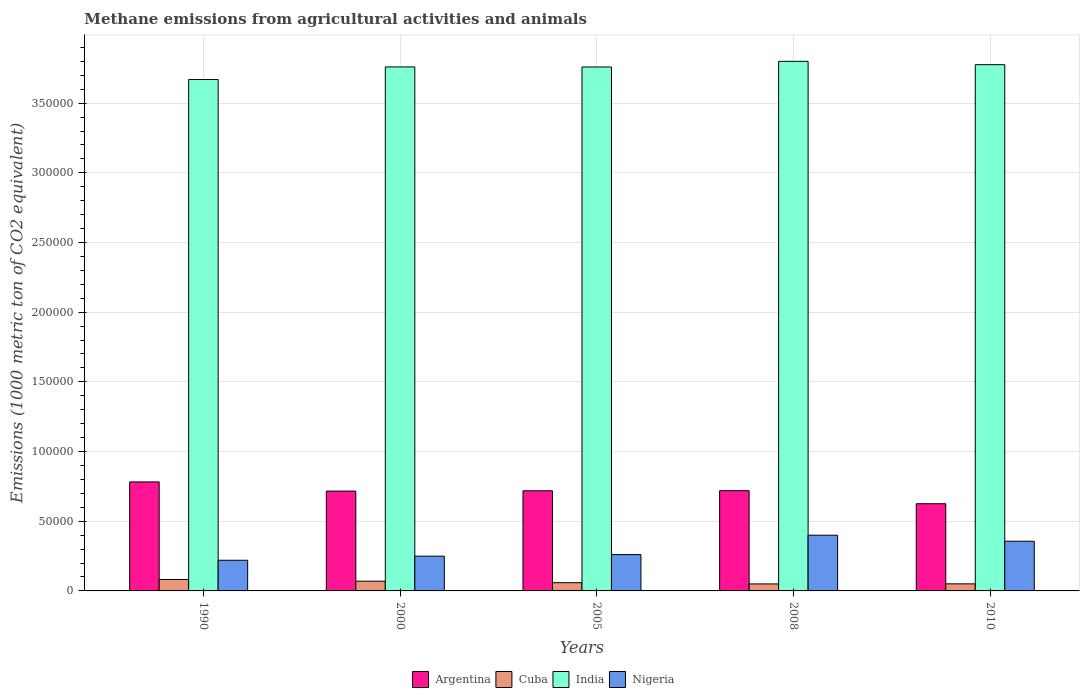How many groups of bars are there?
Your answer should be very brief. 5. Are the number of bars on each tick of the X-axis equal?
Give a very brief answer. Yes. In how many cases, is the number of bars for a given year not equal to the number of legend labels?
Provide a short and direct response. 0. What is the amount of methane emitted in Nigeria in 2008?
Offer a very short reply. 4.00e+04. Across all years, what is the maximum amount of methane emitted in India?
Provide a short and direct response. 3.80e+05. Across all years, what is the minimum amount of methane emitted in Cuba?
Provide a succinct answer. 5015. In which year was the amount of methane emitted in India maximum?
Offer a very short reply. 2008. What is the total amount of methane emitted in India in the graph?
Keep it short and to the point. 1.88e+06. What is the difference between the amount of methane emitted in India in 2005 and that in 2010?
Offer a very short reply. -1660. What is the difference between the amount of methane emitted in Nigeria in 2008 and the amount of methane emitted in Cuba in 2005?
Your response must be concise. 3.41e+04. What is the average amount of methane emitted in Nigeria per year?
Give a very brief answer. 2.97e+04. In the year 2008, what is the difference between the amount of methane emitted in Cuba and amount of methane emitted in Argentina?
Your answer should be very brief. -6.69e+04. In how many years, is the amount of methane emitted in Nigeria greater than 140000 1000 metric ton?
Offer a very short reply. 0. What is the ratio of the amount of methane emitted in Cuba in 1990 to that in 2005?
Your answer should be compact. 1.39. Is the amount of methane emitted in Argentina in 2000 less than that in 2010?
Ensure brevity in your answer.  No. What is the difference between the highest and the second highest amount of methane emitted in Cuba?
Your answer should be compact. 1219.2. What is the difference between the highest and the lowest amount of methane emitted in Cuba?
Make the answer very short. 3192.5. In how many years, is the amount of methane emitted in Cuba greater than the average amount of methane emitted in Cuba taken over all years?
Your answer should be very brief. 2. Is the sum of the amount of methane emitted in India in 1990 and 2008 greater than the maximum amount of methane emitted in Nigeria across all years?
Your response must be concise. Yes. Is it the case that in every year, the sum of the amount of methane emitted in Cuba and amount of methane emitted in India is greater than the sum of amount of methane emitted in Argentina and amount of methane emitted in Nigeria?
Keep it short and to the point. Yes. Is it the case that in every year, the sum of the amount of methane emitted in Cuba and amount of methane emitted in Argentina is greater than the amount of methane emitted in Nigeria?
Keep it short and to the point. Yes. How many bars are there?
Offer a terse response. 20. How many years are there in the graph?
Offer a terse response. 5. Where does the legend appear in the graph?
Ensure brevity in your answer.  Bottom center. How are the legend labels stacked?
Give a very brief answer. Horizontal. What is the title of the graph?
Provide a succinct answer. Methane emissions from agricultural activities and animals. Does "Cote d'Ivoire" appear as one of the legend labels in the graph?
Your response must be concise. No. What is the label or title of the X-axis?
Make the answer very short. Years. What is the label or title of the Y-axis?
Provide a succinct answer. Emissions (1000 metric ton of CO2 equivalent). What is the Emissions (1000 metric ton of CO2 equivalent) in Argentina in 1990?
Offer a terse response. 7.82e+04. What is the Emissions (1000 metric ton of CO2 equivalent) of Cuba in 1990?
Offer a very short reply. 8207.5. What is the Emissions (1000 metric ton of CO2 equivalent) in India in 1990?
Your response must be concise. 3.67e+05. What is the Emissions (1000 metric ton of CO2 equivalent) in Nigeria in 1990?
Offer a very short reply. 2.20e+04. What is the Emissions (1000 metric ton of CO2 equivalent) of Argentina in 2000?
Provide a succinct answer. 7.16e+04. What is the Emissions (1000 metric ton of CO2 equivalent) in Cuba in 2000?
Your answer should be very brief. 6988.3. What is the Emissions (1000 metric ton of CO2 equivalent) in India in 2000?
Give a very brief answer. 3.76e+05. What is the Emissions (1000 metric ton of CO2 equivalent) in Nigeria in 2000?
Give a very brief answer. 2.49e+04. What is the Emissions (1000 metric ton of CO2 equivalent) in Argentina in 2005?
Your response must be concise. 7.19e+04. What is the Emissions (1000 metric ton of CO2 equivalent) of Cuba in 2005?
Provide a succinct answer. 5913.8. What is the Emissions (1000 metric ton of CO2 equivalent) of India in 2005?
Ensure brevity in your answer.  3.76e+05. What is the Emissions (1000 metric ton of CO2 equivalent) in Nigeria in 2005?
Ensure brevity in your answer.  2.61e+04. What is the Emissions (1000 metric ton of CO2 equivalent) in Argentina in 2008?
Give a very brief answer. 7.19e+04. What is the Emissions (1000 metric ton of CO2 equivalent) of Cuba in 2008?
Offer a very short reply. 5015. What is the Emissions (1000 metric ton of CO2 equivalent) in India in 2008?
Ensure brevity in your answer.  3.80e+05. What is the Emissions (1000 metric ton of CO2 equivalent) of Nigeria in 2008?
Make the answer very short. 4.00e+04. What is the Emissions (1000 metric ton of CO2 equivalent) of Argentina in 2010?
Offer a very short reply. 6.26e+04. What is the Emissions (1000 metric ton of CO2 equivalent) in Cuba in 2010?
Offer a very short reply. 5070.2. What is the Emissions (1000 metric ton of CO2 equivalent) in India in 2010?
Keep it short and to the point. 3.78e+05. What is the Emissions (1000 metric ton of CO2 equivalent) of Nigeria in 2010?
Offer a very short reply. 3.57e+04. Across all years, what is the maximum Emissions (1000 metric ton of CO2 equivalent) in Argentina?
Your response must be concise. 7.82e+04. Across all years, what is the maximum Emissions (1000 metric ton of CO2 equivalent) in Cuba?
Your answer should be very brief. 8207.5. Across all years, what is the maximum Emissions (1000 metric ton of CO2 equivalent) of India?
Provide a short and direct response. 3.80e+05. Across all years, what is the maximum Emissions (1000 metric ton of CO2 equivalent) of Nigeria?
Give a very brief answer. 4.00e+04. Across all years, what is the minimum Emissions (1000 metric ton of CO2 equivalent) of Argentina?
Your response must be concise. 6.26e+04. Across all years, what is the minimum Emissions (1000 metric ton of CO2 equivalent) of Cuba?
Give a very brief answer. 5015. Across all years, what is the minimum Emissions (1000 metric ton of CO2 equivalent) in India?
Your answer should be very brief. 3.67e+05. Across all years, what is the minimum Emissions (1000 metric ton of CO2 equivalent) in Nigeria?
Provide a succinct answer. 2.20e+04. What is the total Emissions (1000 metric ton of CO2 equivalent) of Argentina in the graph?
Give a very brief answer. 3.56e+05. What is the total Emissions (1000 metric ton of CO2 equivalent) of Cuba in the graph?
Your response must be concise. 3.12e+04. What is the total Emissions (1000 metric ton of CO2 equivalent) in India in the graph?
Your answer should be compact. 1.88e+06. What is the total Emissions (1000 metric ton of CO2 equivalent) in Nigeria in the graph?
Give a very brief answer. 1.49e+05. What is the difference between the Emissions (1000 metric ton of CO2 equivalent) of Argentina in 1990 and that in 2000?
Make the answer very short. 6588.6. What is the difference between the Emissions (1000 metric ton of CO2 equivalent) in Cuba in 1990 and that in 2000?
Your answer should be very brief. 1219.2. What is the difference between the Emissions (1000 metric ton of CO2 equivalent) in India in 1990 and that in 2000?
Provide a succinct answer. -9029.4. What is the difference between the Emissions (1000 metric ton of CO2 equivalent) in Nigeria in 1990 and that in 2000?
Give a very brief answer. -2935.6. What is the difference between the Emissions (1000 metric ton of CO2 equivalent) of Argentina in 1990 and that in 2005?
Your answer should be compact. 6369.6. What is the difference between the Emissions (1000 metric ton of CO2 equivalent) of Cuba in 1990 and that in 2005?
Make the answer very short. 2293.7. What is the difference between the Emissions (1000 metric ton of CO2 equivalent) in India in 1990 and that in 2005?
Offer a very short reply. -8983.7. What is the difference between the Emissions (1000 metric ton of CO2 equivalent) of Nigeria in 1990 and that in 2005?
Your answer should be compact. -4059.4. What is the difference between the Emissions (1000 metric ton of CO2 equivalent) in Argentina in 1990 and that in 2008?
Give a very brief answer. 6305.5. What is the difference between the Emissions (1000 metric ton of CO2 equivalent) of Cuba in 1990 and that in 2008?
Offer a very short reply. 3192.5. What is the difference between the Emissions (1000 metric ton of CO2 equivalent) of India in 1990 and that in 2008?
Give a very brief answer. -1.30e+04. What is the difference between the Emissions (1000 metric ton of CO2 equivalent) in Nigeria in 1990 and that in 2008?
Ensure brevity in your answer.  -1.80e+04. What is the difference between the Emissions (1000 metric ton of CO2 equivalent) of Argentina in 1990 and that in 2010?
Keep it short and to the point. 1.57e+04. What is the difference between the Emissions (1000 metric ton of CO2 equivalent) of Cuba in 1990 and that in 2010?
Your answer should be very brief. 3137.3. What is the difference between the Emissions (1000 metric ton of CO2 equivalent) in India in 1990 and that in 2010?
Keep it short and to the point. -1.06e+04. What is the difference between the Emissions (1000 metric ton of CO2 equivalent) in Nigeria in 1990 and that in 2010?
Your answer should be very brief. -1.37e+04. What is the difference between the Emissions (1000 metric ton of CO2 equivalent) of Argentina in 2000 and that in 2005?
Ensure brevity in your answer.  -219. What is the difference between the Emissions (1000 metric ton of CO2 equivalent) in Cuba in 2000 and that in 2005?
Ensure brevity in your answer.  1074.5. What is the difference between the Emissions (1000 metric ton of CO2 equivalent) of India in 2000 and that in 2005?
Offer a very short reply. 45.7. What is the difference between the Emissions (1000 metric ton of CO2 equivalent) in Nigeria in 2000 and that in 2005?
Give a very brief answer. -1123.8. What is the difference between the Emissions (1000 metric ton of CO2 equivalent) in Argentina in 2000 and that in 2008?
Give a very brief answer. -283.1. What is the difference between the Emissions (1000 metric ton of CO2 equivalent) of Cuba in 2000 and that in 2008?
Offer a very short reply. 1973.3. What is the difference between the Emissions (1000 metric ton of CO2 equivalent) in India in 2000 and that in 2008?
Ensure brevity in your answer.  -4005.8. What is the difference between the Emissions (1000 metric ton of CO2 equivalent) of Nigeria in 2000 and that in 2008?
Keep it short and to the point. -1.50e+04. What is the difference between the Emissions (1000 metric ton of CO2 equivalent) in Argentina in 2000 and that in 2010?
Your answer should be compact. 9062.7. What is the difference between the Emissions (1000 metric ton of CO2 equivalent) in Cuba in 2000 and that in 2010?
Give a very brief answer. 1918.1. What is the difference between the Emissions (1000 metric ton of CO2 equivalent) of India in 2000 and that in 2010?
Your response must be concise. -1614.3. What is the difference between the Emissions (1000 metric ton of CO2 equivalent) of Nigeria in 2000 and that in 2010?
Provide a succinct answer. -1.07e+04. What is the difference between the Emissions (1000 metric ton of CO2 equivalent) in Argentina in 2005 and that in 2008?
Ensure brevity in your answer.  -64.1. What is the difference between the Emissions (1000 metric ton of CO2 equivalent) of Cuba in 2005 and that in 2008?
Offer a terse response. 898.8. What is the difference between the Emissions (1000 metric ton of CO2 equivalent) in India in 2005 and that in 2008?
Your response must be concise. -4051.5. What is the difference between the Emissions (1000 metric ton of CO2 equivalent) of Nigeria in 2005 and that in 2008?
Offer a terse response. -1.39e+04. What is the difference between the Emissions (1000 metric ton of CO2 equivalent) of Argentina in 2005 and that in 2010?
Your answer should be compact. 9281.7. What is the difference between the Emissions (1000 metric ton of CO2 equivalent) of Cuba in 2005 and that in 2010?
Your answer should be very brief. 843.6. What is the difference between the Emissions (1000 metric ton of CO2 equivalent) in India in 2005 and that in 2010?
Keep it short and to the point. -1660. What is the difference between the Emissions (1000 metric ton of CO2 equivalent) in Nigeria in 2005 and that in 2010?
Keep it short and to the point. -9593.8. What is the difference between the Emissions (1000 metric ton of CO2 equivalent) in Argentina in 2008 and that in 2010?
Provide a short and direct response. 9345.8. What is the difference between the Emissions (1000 metric ton of CO2 equivalent) of Cuba in 2008 and that in 2010?
Keep it short and to the point. -55.2. What is the difference between the Emissions (1000 metric ton of CO2 equivalent) in India in 2008 and that in 2010?
Offer a terse response. 2391.5. What is the difference between the Emissions (1000 metric ton of CO2 equivalent) of Nigeria in 2008 and that in 2010?
Your response must be concise. 4315.8. What is the difference between the Emissions (1000 metric ton of CO2 equivalent) of Argentina in 1990 and the Emissions (1000 metric ton of CO2 equivalent) of Cuba in 2000?
Your response must be concise. 7.12e+04. What is the difference between the Emissions (1000 metric ton of CO2 equivalent) of Argentina in 1990 and the Emissions (1000 metric ton of CO2 equivalent) of India in 2000?
Offer a very short reply. -2.98e+05. What is the difference between the Emissions (1000 metric ton of CO2 equivalent) in Argentina in 1990 and the Emissions (1000 metric ton of CO2 equivalent) in Nigeria in 2000?
Provide a short and direct response. 5.33e+04. What is the difference between the Emissions (1000 metric ton of CO2 equivalent) of Cuba in 1990 and the Emissions (1000 metric ton of CO2 equivalent) of India in 2000?
Make the answer very short. -3.68e+05. What is the difference between the Emissions (1000 metric ton of CO2 equivalent) of Cuba in 1990 and the Emissions (1000 metric ton of CO2 equivalent) of Nigeria in 2000?
Ensure brevity in your answer.  -1.67e+04. What is the difference between the Emissions (1000 metric ton of CO2 equivalent) in India in 1990 and the Emissions (1000 metric ton of CO2 equivalent) in Nigeria in 2000?
Keep it short and to the point. 3.42e+05. What is the difference between the Emissions (1000 metric ton of CO2 equivalent) of Argentina in 1990 and the Emissions (1000 metric ton of CO2 equivalent) of Cuba in 2005?
Make the answer very short. 7.23e+04. What is the difference between the Emissions (1000 metric ton of CO2 equivalent) of Argentina in 1990 and the Emissions (1000 metric ton of CO2 equivalent) of India in 2005?
Give a very brief answer. -2.98e+05. What is the difference between the Emissions (1000 metric ton of CO2 equivalent) in Argentina in 1990 and the Emissions (1000 metric ton of CO2 equivalent) in Nigeria in 2005?
Give a very brief answer. 5.22e+04. What is the difference between the Emissions (1000 metric ton of CO2 equivalent) in Cuba in 1990 and the Emissions (1000 metric ton of CO2 equivalent) in India in 2005?
Provide a short and direct response. -3.68e+05. What is the difference between the Emissions (1000 metric ton of CO2 equivalent) of Cuba in 1990 and the Emissions (1000 metric ton of CO2 equivalent) of Nigeria in 2005?
Your answer should be very brief. -1.79e+04. What is the difference between the Emissions (1000 metric ton of CO2 equivalent) in India in 1990 and the Emissions (1000 metric ton of CO2 equivalent) in Nigeria in 2005?
Give a very brief answer. 3.41e+05. What is the difference between the Emissions (1000 metric ton of CO2 equivalent) in Argentina in 1990 and the Emissions (1000 metric ton of CO2 equivalent) in Cuba in 2008?
Ensure brevity in your answer.  7.32e+04. What is the difference between the Emissions (1000 metric ton of CO2 equivalent) of Argentina in 1990 and the Emissions (1000 metric ton of CO2 equivalent) of India in 2008?
Offer a very short reply. -3.02e+05. What is the difference between the Emissions (1000 metric ton of CO2 equivalent) of Argentina in 1990 and the Emissions (1000 metric ton of CO2 equivalent) of Nigeria in 2008?
Your answer should be compact. 3.82e+04. What is the difference between the Emissions (1000 metric ton of CO2 equivalent) of Cuba in 1990 and the Emissions (1000 metric ton of CO2 equivalent) of India in 2008?
Your response must be concise. -3.72e+05. What is the difference between the Emissions (1000 metric ton of CO2 equivalent) in Cuba in 1990 and the Emissions (1000 metric ton of CO2 equivalent) in Nigeria in 2008?
Ensure brevity in your answer.  -3.18e+04. What is the difference between the Emissions (1000 metric ton of CO2 equivalent) in India in 1990 and the Emissions (1000 metric ton of CO2 equivalent) in Nigeria in 2008?
Offer a very short reply. 3.27e+05. What is the difference between the Emissions (1000 metric ton of CO2 equivalent) in Argentina in 1990 and the Emissions (1000 metric ton of CO2 equivalent) in Cuba in 2010?
Your answer should be very brief. 7.32e+04. What is the difference between the Emissions (1000 metric ton of CO2 equivalent) of Argentina in 1990 and the Emissions (1000 metric ton of CO2 equivalent) of India in 2010?
Your answer should be compact. -2.99e+05. What is the difference between the Emissions (1000 metric ton of CO2 equivalent) in Argentina in 1990 and the Emissions (1000 metric ton of CO2 equivalent) in Nigeria in 2010?
Provide a short and direct response. 4.26e+04. What is the difference between the Emissions (1000 metric ton of CO2 equivalent) of Cuba in 1990 and the Emissions (1000 metric ton of CO2 equivalent) of India in 2010?
Your answer should be compact. -3.69e+05. What is the difference between the Emissions (1000 metric ton of CO2 equivalent) of Cuba in 1990 and the Emissions (1000 metric ton of CO2 equivalent) of Nigeria in 2010?
Offer a very short reply. -2.75e+04. What is the difference between the Emissions (1000 metric ton of CO2 equivalent) of India in 1990 and the Emissions (1000 metric ton of CO2 equivalent) of Nigeria in 2010?
Offer a very short reply. 3.31e+05. What is the difference between the Emissions (1000 metric ton of CO2 equivalent) in Argentina in 2000 and the Emissions (1000 metric ton of CO2 equivalent) in Cuba in 2005?
Provide a succinct answer. 6.57e+04. What is the difference between the Emissions (1000 metric ton of CO2 equivalent) in Argentina in 2000 and the Emissions (1000 metric ton of CO2 equivalent) in India in 2005?
Provide a succinct answer. -3.04e+05. What is the difference between the Emissions (1000 metric ton of CO2 equivalent) in Argentina in 2000 and the Emissions (1000 metric ton of CO2 equivalent) in Nigeria in 2005?
Your response must be concise. 4.56e+04. What is the difference between the Emissions (1000 metric ton of CO2 equivalent) of Cuba in 2000 and the Emissions (1000 metric ton of CO2 equivalent) of India in 2005?
Your response must be concise. -3.69e+05. What is the difference between the Emissions (1000 metric ton of CO2 equivalent) of Cuba in 2000 and the Emissions (1000 metric ton of CO2 equivalent) of Nigeria in 2005?
Your response must be concise. -1.91e+04. What is the difference between the Emissions (1000 metric ton of CO2 equivalent) in India in 2000 and the Emissions (1000 metric ton of CO2 equivalent) in Nigeria in 2005?
Make the answer very short. 3.50e+05. What is the difference between the Emissions (1000 metric ton of CO2 equivalent) in Argentina in 2000 and the Emissions (1000 metric ton of CO2 equivalent) in Cuba in 2008?
Give a very brief answer. 6.66e+04. What is the difference between the Emissions (1000 metric ton of CO2 equivalent) in Argentina in 2000 and the Emissions (1000 metric ton of CO2 equivalent) in India in 2008?
Keep it short and to the point. -3.08e+05. What is the difference between the Emissions (1000 metric ton of CO2 equivalent) in Argentina in 2000 and the Emissions (1000 metric ton of CO2 equivalent) in Nigeria in 2008?
Provide a succinct answer. 3.17e+04. What is the difference between the Emissions (1000 metric ton of CO2 equivalent) in Cuba in 2000 and the Emissions (1000 metric ton of CO2 equivalent) in India in 2008?
Provide a short and direct response. -3.73e+05. What is the difference between the Emissions (1000 metric ton of CO2 equivalent) in Cuba in 2000 and the Emissions (1000 metric ton of CO2 equivalent) in Nigeria in 2008?
Offer a very short reply. -3.30e+04. What is the difference between the Emissions (1000 metric ton of CO2 equivalent) of India in 2000 and the Emissions (1000 metric ton of CO2 equivalent) of Nigeria in 2008?
Your response must be concise. 3.36e+05. What is the difference between the Emissions (1000 metric ton of CO2 equivalent) in Argentina in 2000 and the Emissions (1000 metric ton of CO2 equivalent) in Cuba in 2010?
Your answer should be very brief. 6.66e+04. What is the difference between the Emissions (1000 metric ton of CO2 equivalent) of Argentina in 2000 and the Emissions (1000 metric ton of CO2 equivalent) of India in 2010?
Keep it short and to the point. -3.06e+05. What is the difference between the Emissions (1000 metric ton of CO2 equivalent) in Argentina in 2000 and the Emissions (1000 metric ton of CO2 equivalent) in Nigeria in 2010?
Provide a short and direct response. 3.60e+04. What is the difference between the Emissions (1000 metric ton of CO2 equivalent) of Cuba in 2000 and the Emissions (1000 metric ton of CO2 equivalent) of India in 2010?
Keep it short and to the point. -3.71e+05. What is the difference between the Emissions (1000 metric ton of CO2 equivalent) of Cuba in 2000 and the Emissions (1000 metric ton of CO2 equivalent) of Nigeria in 2010?
Provide a short and direct response. -2.87e+04. What is the difference between the Emissions (1000 metric ton of CO2 equivalent) in India in 2000 and the Emissions (1000 metric ton of CO2 equivalent) in Nigeria in 2010?
Offer a terse response. 3.40e+05. What is the difference between the Emissions (1000 metric ton of CO2 equivalent) of Argentina in 2005 and the Emissions (1000 metric ton of CO2 equivalent) of Cuba in 2008?
Your response must be concise. 6.68e+04. What is the difference between the Emissions (1000 metric ton of CO2 equivalent) in Argentina in 2005 and the Emissions (1000 metric ton of CO2 equivalent) in India in 2008?
Offer a terse response. -3.08e+05. What is the difference between the Emissions (1000 metric ton of CO2 equivalent) of Argentina in 2005 and the Emissions (1000 metric ton of CO2 equivalent) of Nigeria in 2008?
Your answer should be compact. 3.19e+04. What is the difference between the Emissions (1000 metric ton of CO2 equivalent) of Cuba in 2005 and the Emissions (1000 metric ton of CO2 equivalent) of India in 2008?
Keep it short and to the point. -3.74e+05. What is the difference between the Emissions (1000 metric ton of CO2 equivalent) of Cuba in 2005 and the Emissions (1000 metric ton of CO2 equivalent) of Nigeria in 2008?
Keep it short and to the point. -3.41e+04. What is the difference between the Emissions (1000 metric ton of CO2 equivalent) in India in 2005 and the Emissions (1000 metric ton of CO2 equivalent) in Nigeria in 2008?
Ensure brevity in your answer.  3.36e+05. What is the difference between the Emissions (1000 metric ton of CO2 equivalent) in Argentina in 2005 and the Emissions (1000 metric ton of CO2 equivalent) in Cuba in 2010?
Make the answer very short. 6.68e+04. What is the difference between the Emissions (1000 metric ton of CO2 equivalent) of Argentina in 2005 and the Emissions (1000 metric ton of CO2 equivalent) of India in 2010?
Offer a very short reply. -3.06e+05. What is the difference between the Emissions (1000 metric ton of CO2 equivalent) in Argentina in 2005 and the Emissions (1000 metric ton of CO2 equivalent) in Nigeria in 2010?
Keep it short and to the point. 3.62e+04. What is the difference between the Emissions (1000 metric ton of CO2 equivalent) of Cuba in 2005 and the Emissions (1000 metric ton of CO2 equivalent) of India in 2010?
Give a very brief answer. -3.72e+05. What is the difference between the Emissions (1000 metric ton of CO2 equivalent) in Cuba in 2005 and the Emissions (1000 metric ton of CO2 equivalent) in Nigeria in 2010?
Provide a short and direct response. -2.97e+04. What is the difference between the Emissions (1000 metric ton of CO2 equivalent) of India in 2005 and the Emissions (1000 metric ton of CO2 equivalent) of Nigeria in 2010?
Ensure brevity in your answer.  3.40e+05. What is the difference between the Emissions (1000 metric ton of CO2 equivalent) in Argentina in 2008 and the Emissions (1000 metric ton of CO2 equivalent) in Cuba in 2010?
Your answer should be compact. 6.68e+04. What is the difference between the Emissions (1000 metric ton of CO2 equivalent) of Argentina in 2008 and the Emissions (1000 metric ton of CO2 equivalent) of India in 2010?
Ensure brevity in your answer.  -3.06e+05. What is the difference between the Emissions (1000 metric ton of CO2 equivalent) in Argentina in 2008 and the Emissions (1000 metric ton of CO2 equivalent) in Nigeria in 2010?
Provide a succinct answer. 3.63e+04. What is the difference between the Emissions (1000 metric ton of CO2 equivalent) in Cuba in 2008 and the Emissions (1000 metric ton of CO2 equivalent) in India in 2010?
Provide a succinct answer. -3.73e+05. What is the difference between the Emissions (1000 metric ton of CO2 equivalent) in Cuba in 2008 and the Emissions (1000 metric ton of CO2 equivalent) in Nigeria in 2010?
Provide a succinct answer. -3.06e+04. What is the difference between the Emissions (1000 metric ton of CO2 equivalent) of India in 2008 and the Emissions (1000 metric ton of CO2 equivalent) of Nigeria in 2010?
Provide a short and direct response. 3.44e+05. What is the average Emissions (1000 metric ton of CO2 equivalent) in Argentina per year?
Your answer should be compact. 7.12e+04. What is the average Emissions (1000 metric ton of CO2 equivalent) in Cuba per year?
Your answer should be very brief. 6238.96. What is the average Emissions (1000 metric ton of CO2 equivalent) in India per year?
Provide a succinct answer. 3.75e+05. What is the average Emissions (1000 metric ton of CO2 equivalent) of Nigeria per year?
Make the answer very short. 2.97e+04. In the year 1990, what is the difference between the Emissions (1000 metric ton of CO2 equivalent) in Argentina and Emissions (1000 metric ton of CO2 equivalent) in Cuba?
Your response must be concise. 7.00e+04. In the year 1990, what is the difference between the Emissions (1000 metric ton of CO2 equivalent) in Argentina and Emissions (1000 metric ton of CO2 equivalent) in India?
Keep it short and to the point. -2.89e+05. In the year 1990, what is the difference between the Emissions (1000 metric ton of CO2 equivalent) in Argentina and Emissions (1000 metric ton of CO2 equivalent) in Nigeria?
Offer a very short reply. 5.62e+04. In the year 1990, what is the difference between the Emissions (1000 metric ton of CO2 equivalent) in Cuba and Emissions (1000 metric ton of CO2 equivalent) in India?
Offer a very short reply. -3.59e+05. In the year 1990, what is the difference between the Emissions (1000 metric ton of CO2 equivalent) of Cuba and Emissions (1000 metric ton of CO2 equivalent) of Nigeria?
Offer a very short reply. -1.38e+04. In the year 1990, what is the difference between the Emissions (1000 metric ton of CO2 equivalent) of India and Emissions (1000 metric ton of CO2 equivalent) of Nigeria?
Give a very brief answer. 3.45e+05. In the year 2000, what is the difference between the Emissions (1000 metric ton of CO2 equivalent) of Argentina and Emissions (1000 metric ton of CO2 equivalent) of Cuba?
Ensure brevity in your answer.  6.46e+04. In the year 2000, what is the difference between the Emissions (1000 metric ton of CO2 equivalent) of Argentina and Emissions (1000 metric ton of CO2 equivalent) of India?
Offer a very short reply. -3.04e+05. In the year 2000, what is the difference between the Emissions (1000 metric ton of CO2 equivalent) in Argentina and Emissions (1000 metric ton of CO2 equivalent) in Nigeria?
Give a very brief answer. 4.67e+04. In the year 2000, what is the difference between the Emissions (1000 metric ton of CO2 equivalent) in Cuba and Emissions (1000 metric ton of CO2 equivalent) in India?
Provide a succinct answer. -3.69e+05. In the year 2000, what is the difference between the Emissions (1000 metric ton of CO2 equivalent) of Cuba and Emissions (1000 metric ton of CO2 equivalent) of Nigeria?
Give a very brief answer. -1.80e+04. In the year 2000, what is the difference between the Emissions (1000 metric ton of CO2 equivalent) of India and Emissions (1000 metric ton of CO2 equivalent) of Nigeria?
Make the answer very short. 3.51e+05. In the year 2005, what is the difference between the Emissions (1000 metric ton of CO2 equivalent) of Argentina and Emissions (1000 metric ton of CO2 equivalent) of Cuba?
Make the answer very short. 6.59e+04. In the year 2005, what is the difference between the Emissions (1000 metric ton of CO2 equivalent) in Argentina and Emissions (1000 metric ton of CO2 equivalent) in India?
Offer a very short reply. -3.04e+05. In the year 2005, what is the difference between the Emissions (1000 metric ton of CO2 equivalent) of Argentina and Emissions (1000 metric ton of CO2 equivalent) of Nigeria?
Make the answer very short. 4.58e+04. In the year 2005, what is the difference between the Emissions (1000 metric ton of CO2 equivalent) in Cuba and Emissions (1000 metric ton of CO2 equivalent) in India?
Your answer should be very brief. -3.70e+05. In the year 2005, what is the difference between the Emissions (1000 metric ton of CO2 equivalent) in Cuba and Emissions (1000 metric ton of CO2 equivalent) in Nigeria?
Your answer should be compact. -2.02e+04. In the year 2005, what is the difference between the Emissions (1000 metric ton of CO2 equivalent) of India and Emissions (1000 metric ton of CO2 equivalent) of Nigeria?
Keep it short and to the point. 3.50e+05. In the year 2008, what is the difference between the Emissions (1000 metric ton of CO2 equivalent) of Argentina and Emissions (1000 metric ton of CO2 equivalent) of Cuba?
Offer a very short reply. 6.69e+04. In the year 2008, what is the difference between the Emissions (1000 metric ton of CO2 equivalent) in Argentina and Emissions (1000 metric ton of CO2 equivalent) in India?
Ensure brevity in your answer.  -3.08e+05. In the year 2008, what is the difference between the Emissions (1000 metric ton of CO2 equivalent) of Argentina and Emissions (1000 metric ton of CO2 equivalent) of Nigeria?
Provide a succinct answer. 3.19e+04. In the year 2008, what is the difference between the Emissions (1000 metric ton of CO2 equivalent) in Cuba and Emissions (1000 metric ton of CO2 equivalent) in India?
Provide a succinct answer. -3.75e+05. In the year 2008, what is the difference between the Emissions (1000 metric ton of CO2 equivalent) in Cuba and Emissions (1000 metric ton of CO2 equivalent) in Nigeria?
Your answer should be very brief. -3.50e+04. In the year 2008, what is the difference between the Emissions (1000 metric ton of CO2 equivalent) in India and Emissions (1000 metric ton of CO2 equivalent) in Nigeria?
Give a very brief answer. 3.40e+05. In the year 2010, what is the difference between the Emissions (1000 metric ton of CO2 equivalent) in Argentina and Emissions (1000 metric ton of CO2 equivalent) in Cuba?
Provide a short and direct response. 5.75e+04. In the year 2010, what is the difference between the Emissions (1000 metric ton of CO2 equivalent) in Argentina and Emissions (1000 metric ton of CO2 equivalent) in India?
Your answer should be compact. -3.15e+05. In the year 2010, what is the difference between the Emissions (1000 metric ton of CO2 equivalent) of Argentina and Emissions (1000 metric ton of CO2 equivalent) of Nigeria?
Provide a succinct answer. 2.69e+04. In the year 2010, what is the difference between the Emissions (1000 metric ton of CO2 equivalent) of Cuba and Emissions (1000 metric ton of CO2 equivalent) of India?
Offer a terse response. -3.73e+05. In the year 2010, what is the difference between the Emissions (1000 metric ton of CO2 equivalent) of Cuba and Emissions (1000 metric ton of CO2 equivalent) of Nigeria?
Your response must be concise. -3.06e+04. In the year 2010, what is the difference between the Emissions (1000 metric ton of CO2 equivalent) in India and Emissions (1000 metric ton of CO2 equivalent) in Nigeria?
Keep it short and to the point. 3.42e+05. What is the ratio of the Emissions (1000 metric ton of CO2 equivalent) of Argentina in 1990 to that in 2000?
Ensure brevity in your answer.  1.09. What is the ratio of the Emissions (1000 metric ton of CO2 equivalent) of Cuba in 1990 to that in 2000?
Give a very brief answer. 1.17. What is the ratio of the Emissions (1000 metric ton of CO2 equivalent) of Nigeria in 1990 to that in 2000?
Your answer should be very brief. 0.88. What is the ratio of the Emissions (1000 metric ton of CO2 equivalent) in Argentina in 1990 to that in 2005?
Offer a terse response. 1.09. What is the ratio of the Emissions (1000 metric ton of CO2 equivalent) of Cuba in 1990 to that in 2005?
Your answer should be very brief. 1.39. What is the ratio of the Emissions (1000 metric ton of CO2 equivalent) in India in 1990 to that in 2005?
Offer a very short reply. 0.98. What is the ratio of the Emissions (1000 metric ton of CO2 equivalent) of Nigeria in 1990 to that in 2005?
Offer a very short reply. 0.84. What is the ratio of the Emissions (1000 metric ton of CO2 equivalent) in Argentina in 1990 to that in 2008?
Offer a terse response. 1.09. What is the ratio of the Emissions (1000 metric ton of CO2 equivalent) of Cuba in 1990 to that in 2008?
Provide a short and direct response. 1.64. What is the ratio of the Emissions (1000 metric ton of CO2 equivalent) in India in 1990 to that in 2008?
Offer a very short reply. 0.97. What is the ratio of the Emissions (1000 metric ton of CO2 equivalent) in Nigeria in 1990 to that in 2008?
Ensure brevity in your answer.  0.55. What is the ratio of the Emissions (1000 metric ton of CO2 equivalent) in Argentina in 1990 to that in 2010?
Offer a very short reply. 1.25. What is the ratio of the Emissions (1000 metric ton of CO2 equivalent) in Cuba in 1990 to that in 2010?
Ensure brevity in your answer.  1.62. What is the ratio of the Emissions (1000 metric ton of CO2 equivalent) in India in 1990 to that in 2010?
Offer a very short reply. 0.97. What is the ratio of the Emissions (1000 metric ton of CO2 equivalent) in Nigeria in 1990 to that in 2010?
Make the answer very short. 0.62. What is the ratio of the Emissions (1000 metric ton of CO2 equivalent) in Argentina in 2000 to that in 2005?
Provide a succinct answer. 1. What is the ratio of the Emissions (1000 metric ton of CO2 equivalent) in Cuba in 2000 to that in 2005?
Provide a succinct answer. 1.18. What is the ratio of the Emissions (1000 metric ton of CO2 equivalent) in India in 2000 to that in 2005?
Provide a succinct answer. 1. What is the ratio of the Emissions (1000 metric ton of CO2 equivalent) in Nigeria in 2000 to that in 2005?
Offer a terse response. 0.96. What is the ratio of the Emissions (1000 metric ton of CO2 equivalent) in Cuba in 2000 to that in 2008?
Make the answer very short. 1.39. What is the ratio of the Emissions (1000 metric ton of CO2 equivalent) of Nigeria in 2000 to that in 2008?
Provide a short and direct response. 0.62. What is the ratio of the Emissions (1000 metric ton of CO2 equivalent) in Argentina in 2000 to that in 2010?
Ensure brevity in your answer.  1.14. What is the ratio of the Emissions (1000 metric ton of CO2 equivalent) in Cuba in 2000 to that in 2010?
Offer a terse response. 1.38. What is the ratio of the Emissions (1000 metric ton of CO2 equivalent) of Nigeria in 2000 to that in 2010?
Your response must be concise. 0.7. What is the ratio of the Emissions (1000 metric ton of CO2 equivalent) in Argentina in 2005 to that in 2008?
Your answer should be very brief. 1. What is the ratio of the Emissions (1000 metric ton of CO2 equivalent) of Cuba in 2005 to that in 2008?
Offer a terse response. 1.18. What is the ratio of the Emissions (1000 metric ton of CO2 equivalent) in India in 2005 to that in 2008?
Keep it short and to the point. 0.99. What is the ratio of the Emissions (1000 metric ton of CO2 equivalent) in Nigeria in 2005 to that in 2008?
Offer a very short reply. 0.65. What is the ratio of the Emissions (1000 metric ton of CO2 equivalent) in Argentina in 2005 to that in 2010?
Offer a very short reply. 1.15. What is the ratio of the Emissions (1000 metric ton of CO2 equivalent) of Cuba in 2005 to that in 2010?
Your response must be concise. 1.17. What is the ratio of the Emissions (1000 metric ton of CO2 equivalent) in Nigeria in 2005 to that in 2010?
Ensure brevity in your answer.  0.73. What is the ratio of the Emissions (1000 metric ton of CO2 equivalent) of Argentina in 2008 to that in 2010?
Make the answer very short. 1.15. What is the ratio of the Emissions (1000 metric ton of CO2 equivalent) in Nigeria in 2008 to that in 2010?
Provide a short and direct response. 1.12. What is the difference between the highest and the second highest Emissions (1000 metric ton of CO2 equivalent) in Argentina?
Keep it short and to the point. 6305.5. What is the difference between the highest and the second highest Emissions (1000 metric ton of CO2 equivalent) in Cuba?
Offer a terse response. 1219.2. What is the difference between the highest and the second highest Emissions (1000 metric ton of CO2 equivalent) in India?
Provide a succinct answer. 2391.5. What is the difference between the highest and the second highest Emissions (1000 metric ton of CO2 equivalent) of Nigeria?
Provide a succinct answer. 4315.8. What is the difference between the highest and the lowest Emissions (1000 metric ton of CO2 equivalent) of Argentina?
Make the answer very short. 1.57e+04. What is the difference between the highest and the lowest Emissions (1000 metric ton of CO2 equivalent) in Cuba?
Provide a succinct answer. 3192.5. What is the difference between the highest and the lowest Emissions (1000 metric ton of CO2 equivalent) in India?
Provide a succinct answer. 1.30e+04. What is the difference between the highest and the lowest Emissions (1000 metric ton of CO2 equivalent) in Nigeria?
Give a very brief answer. 1.80e+04. 